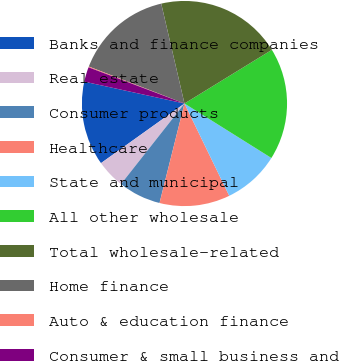<chart> <loc_0><loc_0><loc_500><loc_500><pie_chart><fcel>Banks and finance companies<fcel>Real estate<fcel>Consumer products<fcel>Healthcare<fcel>State and municipal<fcel>All other wholesale<fcel>Total wholesale-related<fcel>Home finance<fcel>Auto & education finance<fcel>Consumer & small business and<nl><fcel>13.29%<fcel>4.51%<fcel>6.71%<fcel>11.1%<fcel>8.9%<fcel>17.68%<fcel>19.87%<fcel>15.49%<fcel>0.13%<fcel>2.32%<nl></chart> 